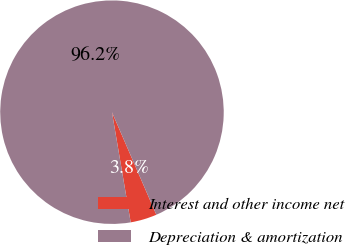Convert chart. <chart><loc_0><loc_0><loc_500><loc_500><pie_chart><fcel>Interest and other income net<fcel>Depreciation & amortization<nl><fcel>3.82%<fcel>96.18%<nl></chart> 